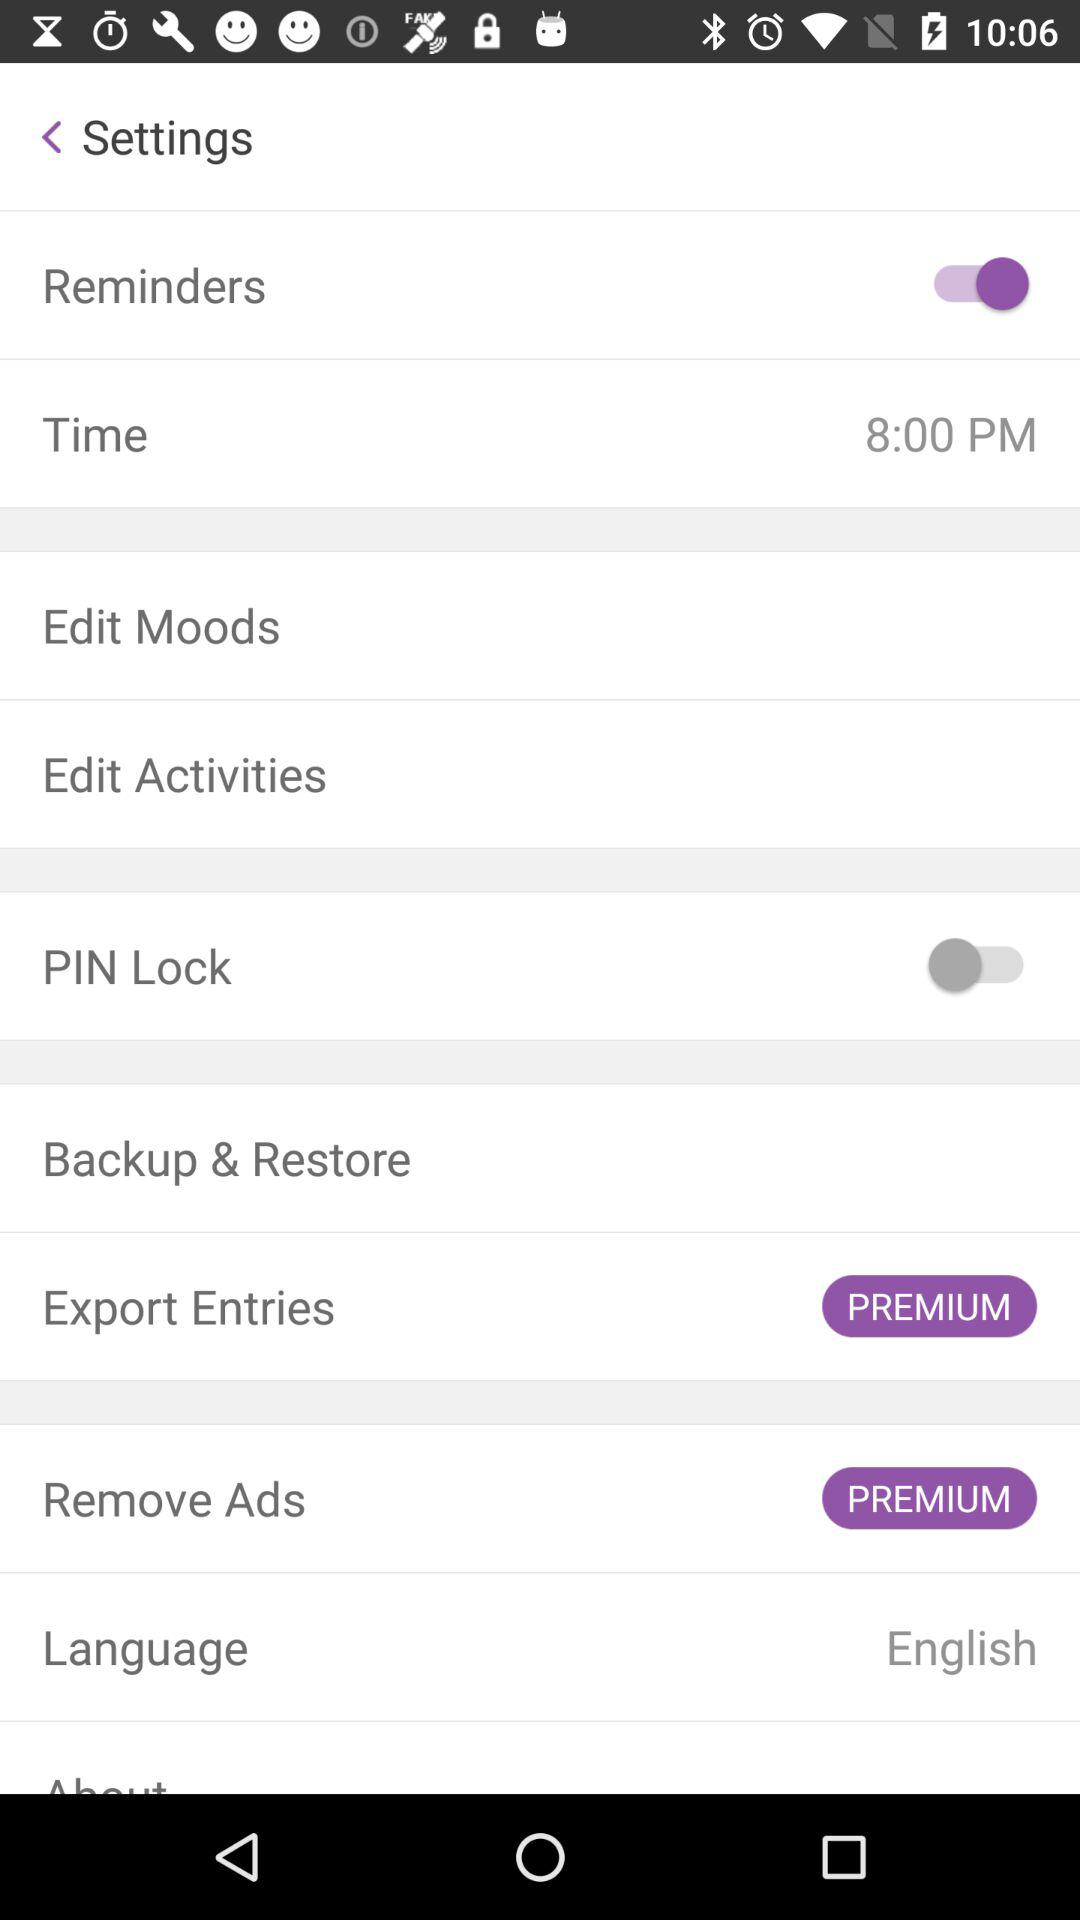What is the mentioned time? The mentioned time is 8:00 PM. 